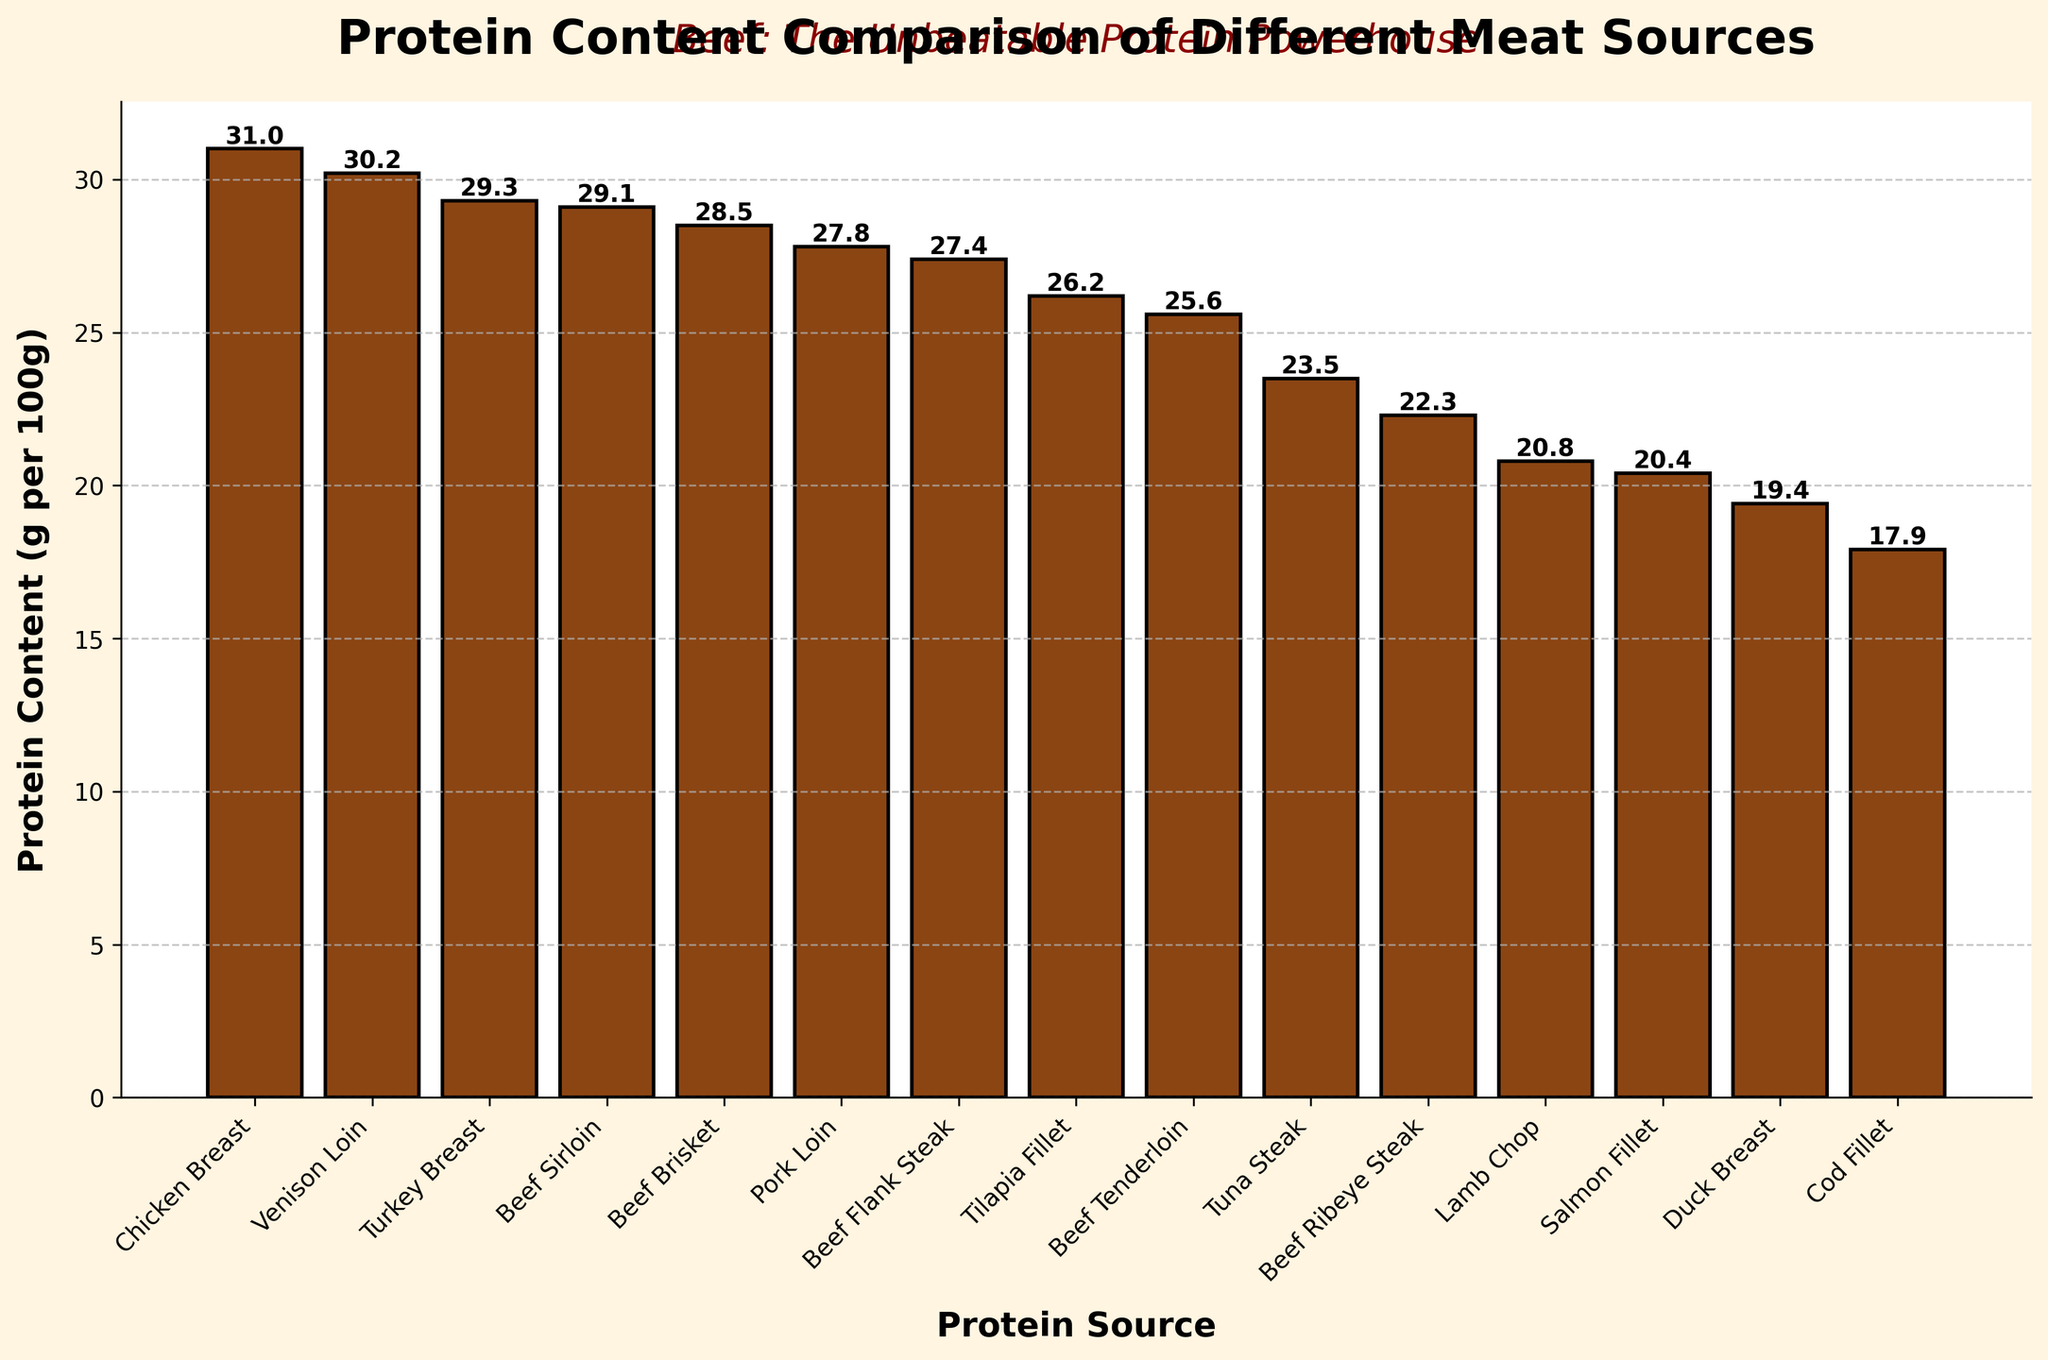Which protein source has the highest protein content? Look at the top bar on the bar chart, which represents the protein source with the highest protein content.
Answer: Chicken Breast What is the difference in protein content between the highest and lowest protein sources? Identify the bars representing the highest and lowest protein sources. They are Chicken Breast (31.0g) and Cod Fillet (17.9g) respectively. Subtract the protein content of Cod Fillet from that of Chicken Breast: 31.0 - 17.9 = 13.1g.
Answer: 13.1g Which protein source has the lowest protein content? Look at the bottom bar on the bar chart, which represents the protein source with the lowest protein content.
Answer: Cod Fillet How many meat sources contain more than 25g of protein per 100g? Count the bars that extend above the 25g mark on the y-axis. The protein sources are Chicken Breast, Beef Sirloin, Tuna Steak, Pork Loin, Turkey Breast, Beef Tenderloin, Beef Brisket, Tilapia Fillet, and Venison Loin.
Answer: 9 What is the average protein content of beef sources? Identify the beef sources from the bars (Beef Ribeye Steak, Beef Sirloin, Beef Tenderloin, Beef Brisket, Beef Flank Steak) and sum their protein contents (22.3 + 29.1 + 25.6 + 28.5 + 27.4 = 132.9). Then divide by the number of sources (132.9 / 5 = 26.58g).
Answer: 26.58g Which protein source is highlighted with a different color compared to most of the others? Look at the bars that are highlighted with a color distinct from the typical bar color. They represent the beef sources: Beef Ribeye Steak, Beef Sirloin, Beef Tenderloin, Beef Brisket, and Beef Flank Steak.
Answer: Beef sources Does any beef source have a higher protein content than Venison Loin? Check if any of the beef source bars surpass the height of the Venison Loin bar (30.2g). None of the beef sources exceed this height.
Answer: No Which two protein sources have the closest protein content values? Compare the heights of the bars to find the ones that are nearly the same. Beef Tenderloin (25.6g) and Tilapia Fillet (26.2g) are very close. Calculate the difference: 26.2 - 25.6 = 0.6g.
Answer: Beef Tenderloin and Tilapia Fillet Is the protein content of Beef Sirloin closer to that of Chicken Breast or Beef Flank Steak? Find the protein content values for Beef Sirloin (29.1g), Chicken Breast (31.0g), and Beef Flank Steak (27.4g). Calculate the differences: 31.0 - 29.1 = 1.9g and 29.1 - 27.4 = 1.7g. Beef Sirloin is closer to Beef Flank Steak.
Answer: Beef Flank Steak 